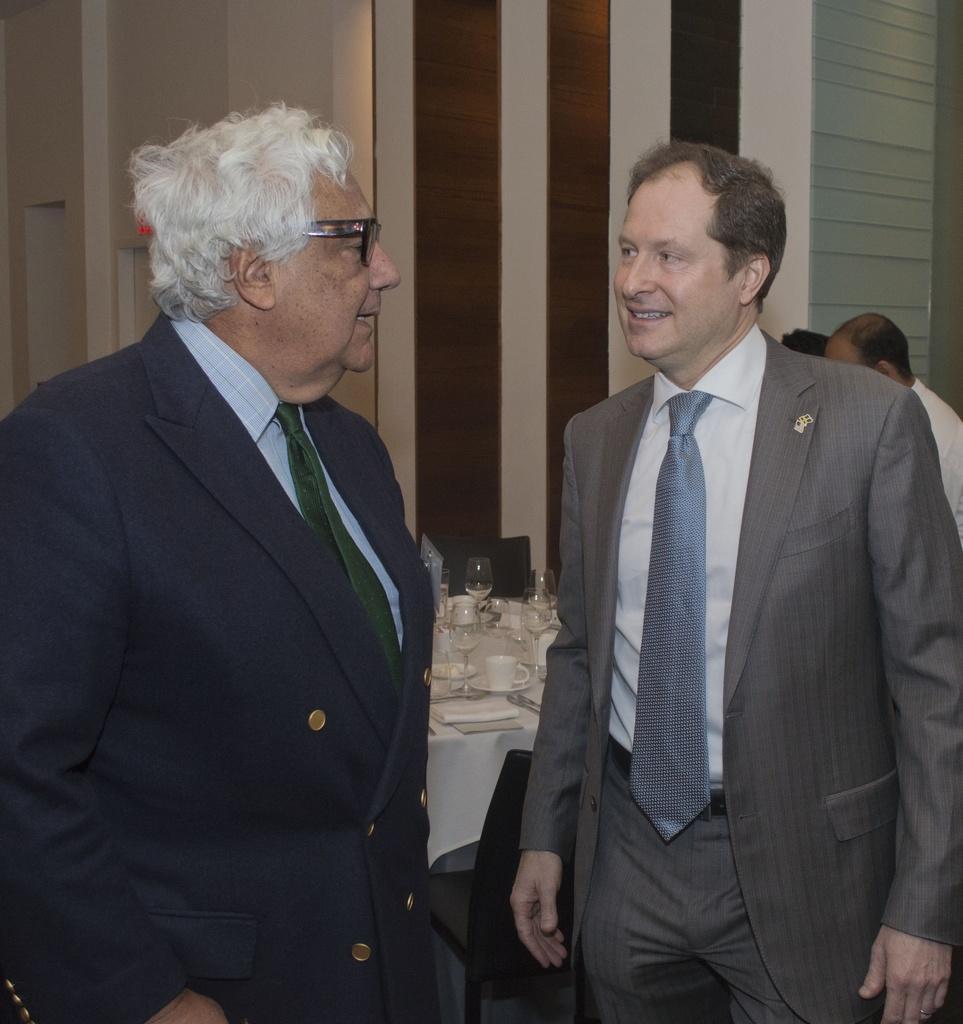How would you summarize this image in a sentence or two? In this image, there are a few people. We can see a table covered with a cloth with some objects like glasses and cups. We can also see some chairs and the wall. 